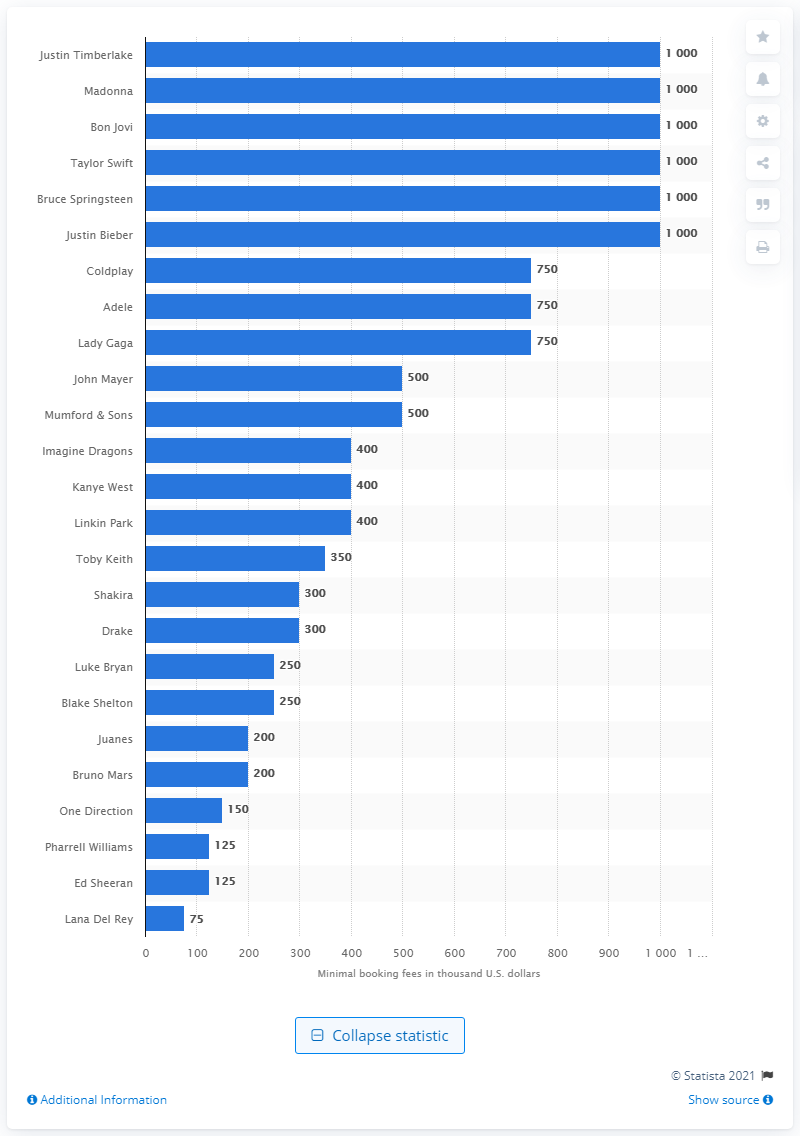Highlight a few significant elements in this photo. The amount that Juanes was paid for a concert was 200.. Juanes, a Latin Grammy winner, is known for charging a minimum of 200 thousand U.S. dollars for his concerts. 